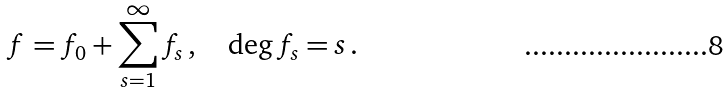<formula> <loc_0><loc_0><loc_500><loc_500>f = f _ { 0 } + \sum _ { s = 1 } ^ { \infty } f _ { s } \, , \quad \deg { f _ { s } } = s \, .</formula> 